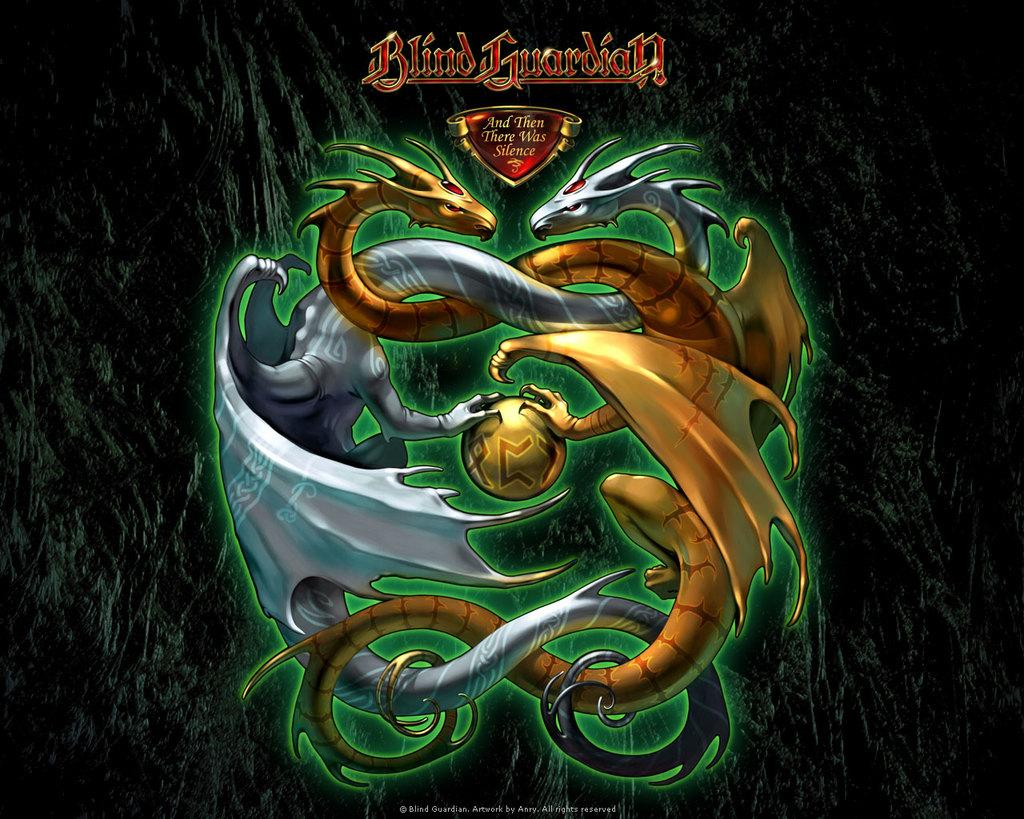What type of picture is the image? The image is an animated picture. What creatures are present in the image? There are dragons in the image. Is there any branding or identification in the image? Yes, there is a logo in the image. Are there any words or letters in the image? Yes, there is text in the image. Where is the watermark located in the image? The watermark is at the bottom of the image. How does the chain balance the wash in the image? There is no chain, balance, or wash present in the image; it features animated dragons, a logo, text, and a watermark. 